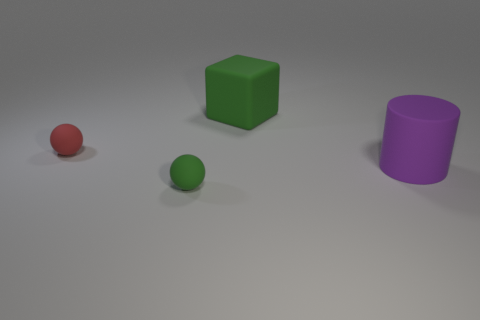Are there any other things that have the same material as the red object?
Keep it short and to the point. Yes. What is the block made of?
Offer a very short reply. Rubber. What is the material of the tiny ball behind the green sphere?
Your answer should be compact. Rubber. Is there any other thing of the same color as the cylinder?
Keep it short and to the point. No. What is the size of the red thing that is the same material as the purple cylinder?
Your answer should be compact. Small. How many tiny things are either red matte things or yellow rubber cylinders?
Make the answer very short. 1. There is a rubber thing that is to the right of the green thing behind the matte sphere in front of the purple cylinder; how big is it?
Offer a terse response. Large. How many blocks have the same size as the red ball?
Offer a very short reply. 0. What number of things are either cylinders or rubber things on the left side of the big purple rubber cylinder?
Your answer should be very brief. 4. The large purple rubber thing is what shape?
Your answer should be compact. Cylinder. 